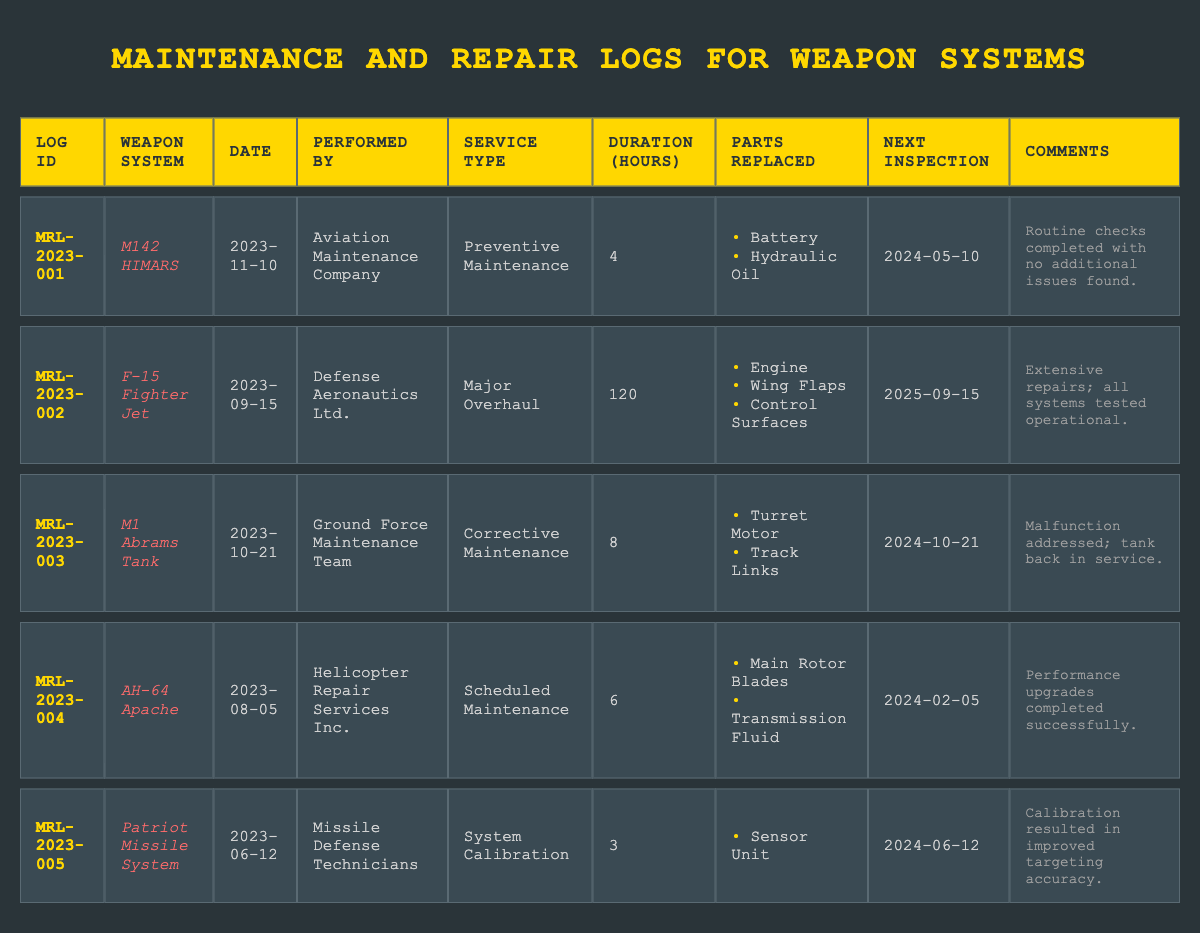What is the service type for the F-15 Fighter Jet? In the table, locate the row for the F-15 Fighter Jet which is listed under the "Weapon System" column. The corresponding "Service Type" for that row indicates it was a Major Overhaul.
Answer: Major Overhaul How many parts were replaced during the maintenance of the M1 Abrams Tank? To find the number of parts replaced for the M1 Abrams Tank, look at the row for the M1 Abrams Tank in the "Parts Replaced" column. There are two parts listed: Turret Motor and Track Links. Thus, the total count is 2.
Answer: 2 What is the average maintenance duration across all weapon systems? First, sum the maintenance durations from all entries: 4 + 120 + 8 + 6 + 3 = 141. There are five entries, so the average is 141 divided by 5, which equals 28.2.
Answer: 28.2 Was the maintenance performed on the AH-64 Apache a major overhaul? Check the row related to the AH-64 Apache in the "Service Type" column which indicates it was Scheduled Maintenance, not a Major Overhaul. Therefore, the answer is no.
Answer: No What is the next inspection date for the Patriot Missile System? Locate the row for the Patriot Missile System and find its "Next Inspection" column. It states the date is 2024-06-12.
Answer: 2024-06-12 How many maintenance entries were performed in 2023? Count the total number of log entries from the "Date" column that fall within the year 2023. There are five entries, all dated in 2023.
Answer: 5 Did any entry mention performance upgrades? Review the comments in the table for any indication of performance upgrades. The entry for the AH-64 Apache notes that performance upgrades were completed successfully, confirming the fact is true.
Answer: Yes Which weapon system had the longest maintenance duration? Compare the "Maintenance Duration" values across all entries. The F-15 Fighter Jet has the highest value at 120 hours, making it the longest maintenance duration recorded.
Answer: F-15 Fighter Jet 